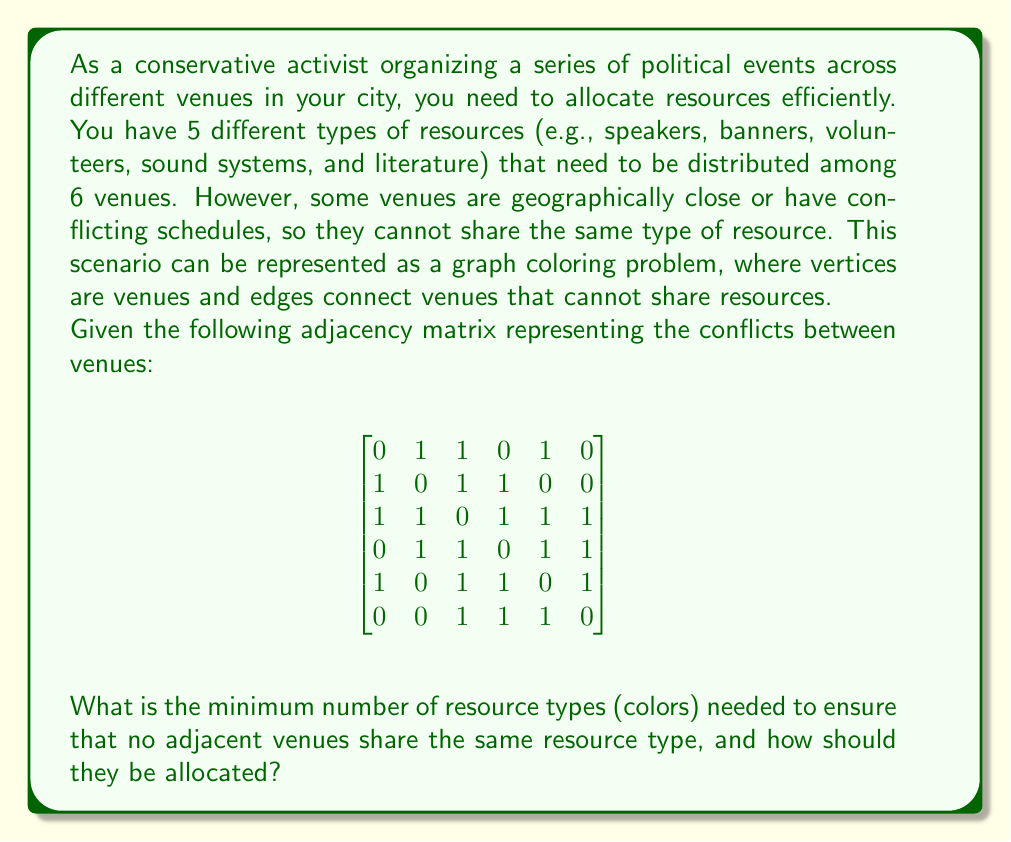Teach me how to tackle this problem. To solve this graph coloring problem, we'll follow these steps:

1) First, let's visualize the graph based on the adjacency matrix:

[asy]
import graph;

size(200);

void drawNode(pair p, string s) {
  fill(circle(p, 0.3), white);
  draw(circle(p, 0.3));
  label(s, p);
}

pair[] v = {(0,2), (2,2), (1,1), (2,0), (0,0), (1,-1)};

for (int i = 0; i < 6; ++i)
  drawNode(v[i], string(i+1));

draw(v[0]--v[1]--v[2]--v[3]--v[4]--v[2]--v[0]--v[4]);
draw(v[1]--v[3]);
draw(v[2]--v[5]--v[3]);
draw(v[4]--v[5]);
[/asy]

2) We'll use the greedy coloring algorithm to color the graph:
   - Start with the first vertex and assign it the first color.
   - For each subsequent vertex, assign it the lowest-numbered color that hasn't been used by its adjacent vertices.

3) Let's color the vertices in order:
   - Vertex 1: Color 1
   - Vertex 2: Color 2 (adjacent to 1)
   - Vertex 3: Color 3 (adjacent to 1 and 2)
   - Vertex 4: Color 1 (not adjacent to 1)
   - Vertex 5: Color 2 (adjacent to 1, 3, 4)
   - Vertex 6: Color 1 (adjacent to 3, 4, 5)

4) The coloring uses 3 colors, which is the minimum number needed for this graph.

5) To allocate resources:
   - Color 1 (e.g., speakers): Venues 1, 4, 6
   - Color 2 (e.g., banners): Venues 2, 5
   - Color 3 (e.g., volunteers): Venue 3
   - The remaining two resource types are not needed for optimal allocation.
Answer: The minimum number of resource types (colors) needed is 3. The allocation should be:
- Resource type 1: Venues 1, 4, 6
- Resource type 2: Venues 2, 5
- Resource type 3: Venue 3 